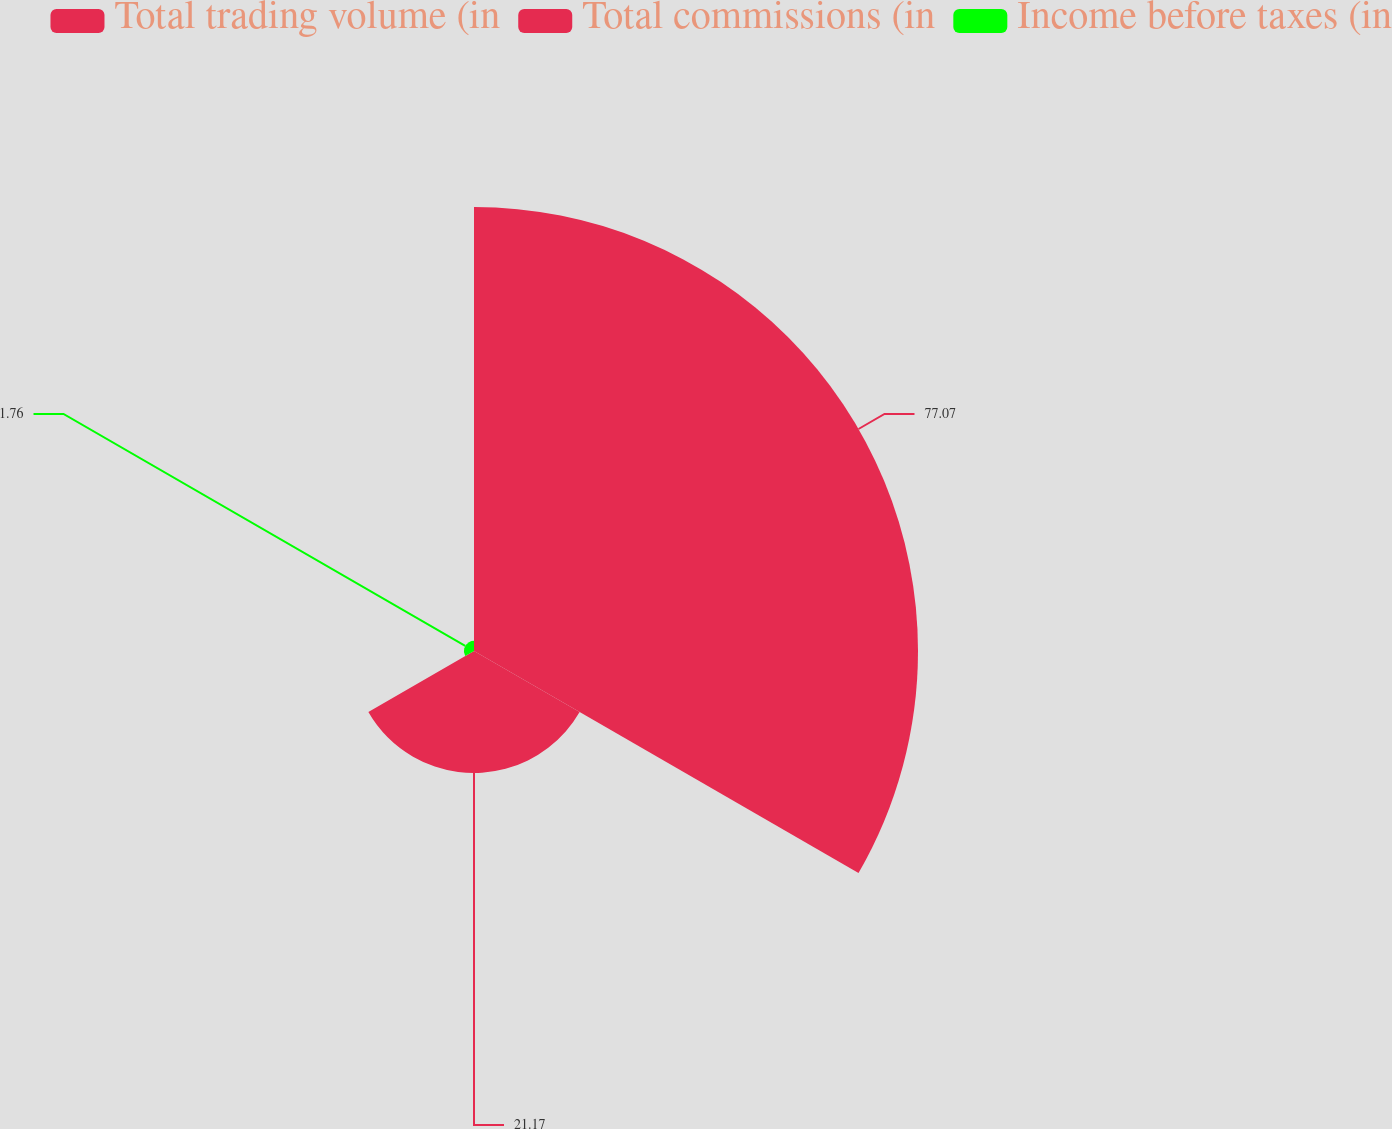Convert chart to OTSL. <chart><loc_0><loc_0><loc_500><loc_500><pie_chart><fcel>Total trading volume (in<fcel>Total commissions (in<fcel>Income before taxes (in<nl><fcel>77.06%<fcel>21.17%<fcel>1.76%<nl></chart> 